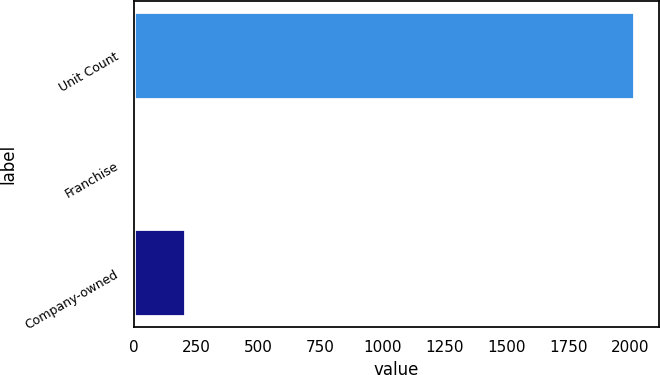Convert chart to OTSL. <chart><loc_0><loc_0><loc_500><loc_500><bar_chart><fcel>Unit Count<fcel>Franchise<fcel>Company-owned<nl><fcel>2015<fcel>3<fcel>204.2<nl></chart> 